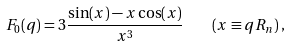Convert formula to latex. <formula><loc_0><loc_0><loc_500><loc_500>F _ { 0 } ( q ) = 3 \frac { \sin ( x ) - x \cos ( x ) } { x ^ { 3 } } \quad ( x \equiv q R _ { n } ) \, ,</formula> 